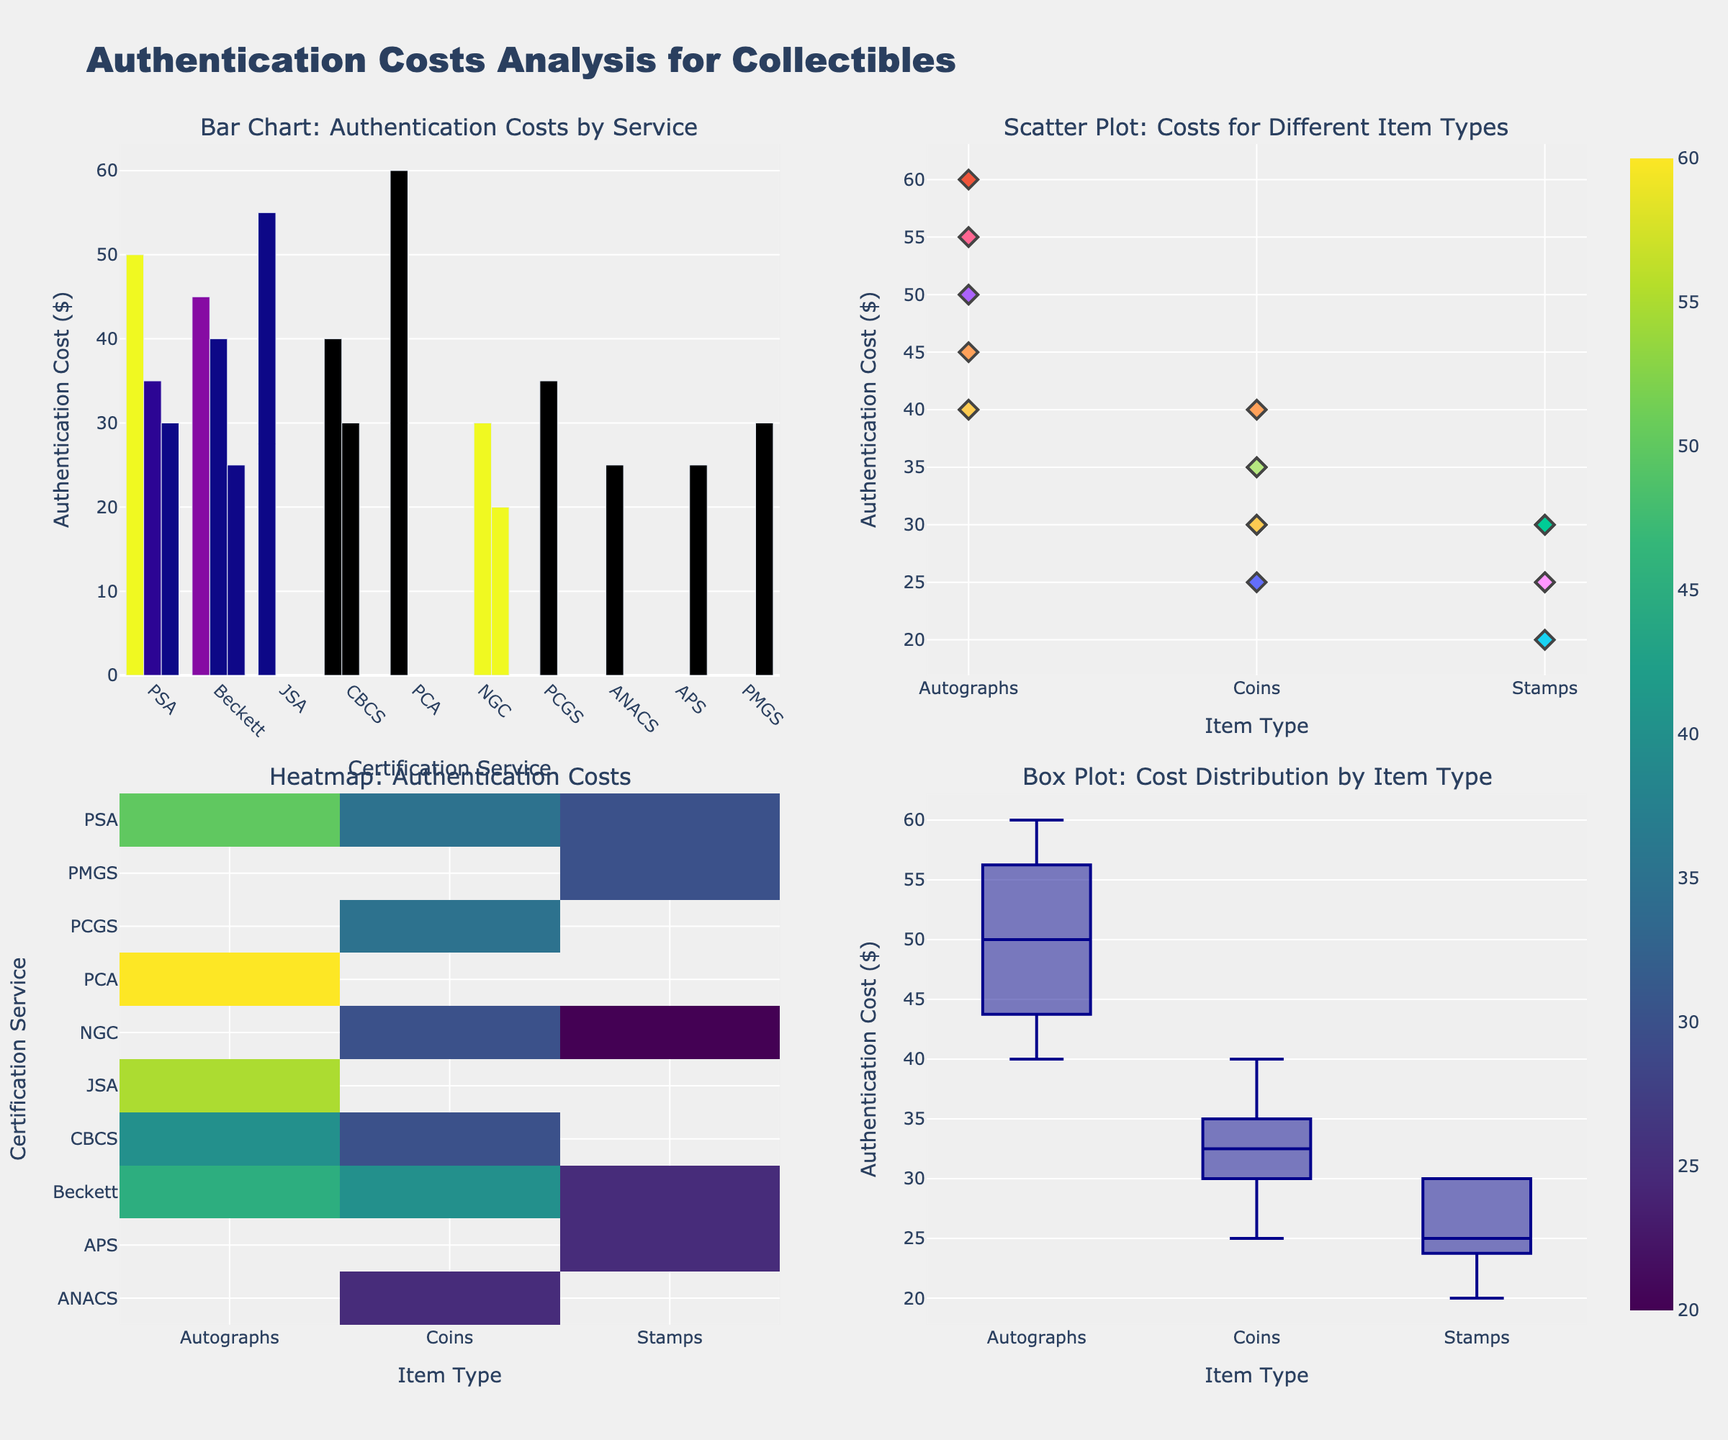What is the title of the subplot in the top-left corner? The title of the subplot in the top-left corner is "Bar Chart: Authentication Costs by Service". Titles are usually found above each plot, and this title is explicitly given in the subplot titles when creating the figure.
Answer: Bar Chart: Authentication Costs by Service Which certification service has the highest authentication cost for autographs? To find the certification service with the highest authentication cost for autographs, look at the bar chart in the top-left subplot and identify the tallest bar in the "Autographs" category. This bar belongs to PCA, with a cost of 60.
Answer: PCA What is the range of authentication costs for coins? The range of authentication costs for coins can be found by looking at all subplots but primarily focusing on the box plot in the bottom-right corner. The minimum cost for coins is 25, and the maximum is 40, so the range is 40 - 25.
Answer: 15 Which item type has the most data points in the scatter plot? In the scatter plot, count the number of markers for each item type. Since each item type appears multiple times, it's clearer to check for item type redundancy and plot density. The "Coins" category seems to have the most data points.
Answer: Coins How does the authentication cost for stamps from Beckett compare with those from other services? To compare Beckett's authentication costs for stamps with other services, check the bar chart and the heatmap. Beckett's cost for stamps is 25. Compared to other services, Beckett's cost is lower than PSA and PMGS (both 30), equal to APS (25), and higher than NGC (20).
Answer: Lower than PSA and PMGS, equal to APS, higher than NGC Which subplot shows variability in authentication costs for different item types? The box plot in the bottom-right corner shows the distribution and variability of authentication costs across different item types. Each box represents the spread of costs within an item type; it visually represents variability.
Answer: The box plot (bottom-right corner) What is the average authentication cost for autographs? To find the average authentication cost for autographs, identify each cost from the datasets within the subplots: PSA (50), Beckett (45), JSA (55), CBCS (40), PCA (60). Calculate the sum: 50 + 45 + 55 + 40 + 60 = 250. Divide by the number of services: 250 / 5 = 50.
Answer: 50 Which item type is generally the cheapest to authenticate based on the heatmap? The heatmap can be inspected for the lowest values across the different services for each item type. "Stamps" generally have lower costs, with values like 20 (NGC), 25 (Beckett, APS), 30 (PSA, PMGS).
Answer: Stamps Which certification service provides the cheapest authentication cost for coins? The coins' authentication costs across services are displayed in several subplots, but easiest in the heatmap and bar chart. ANACS provides the cheapest authentication cost for coins at 25.
Answer: ANACS 